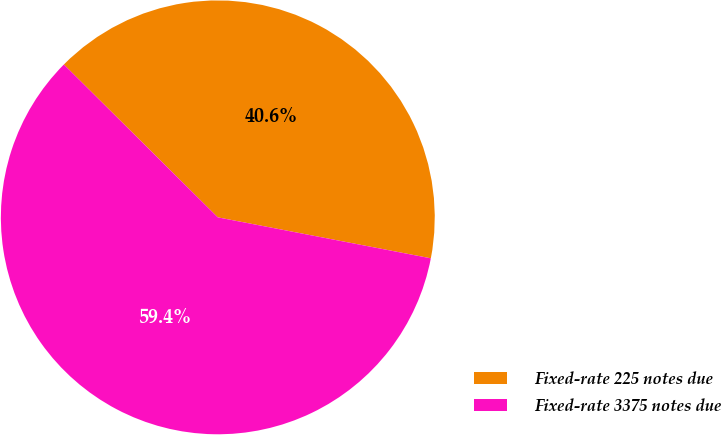Convert chart to OTSL. <chart><loc_0><loc_0><loc_500><loc_500><pie_chart><fcel>Fixed-rate 225 notes due<fcel>Fixed-rate 3375 notes due<nl><fcel>40.58%<fcel>59.42%<nl></chart> 